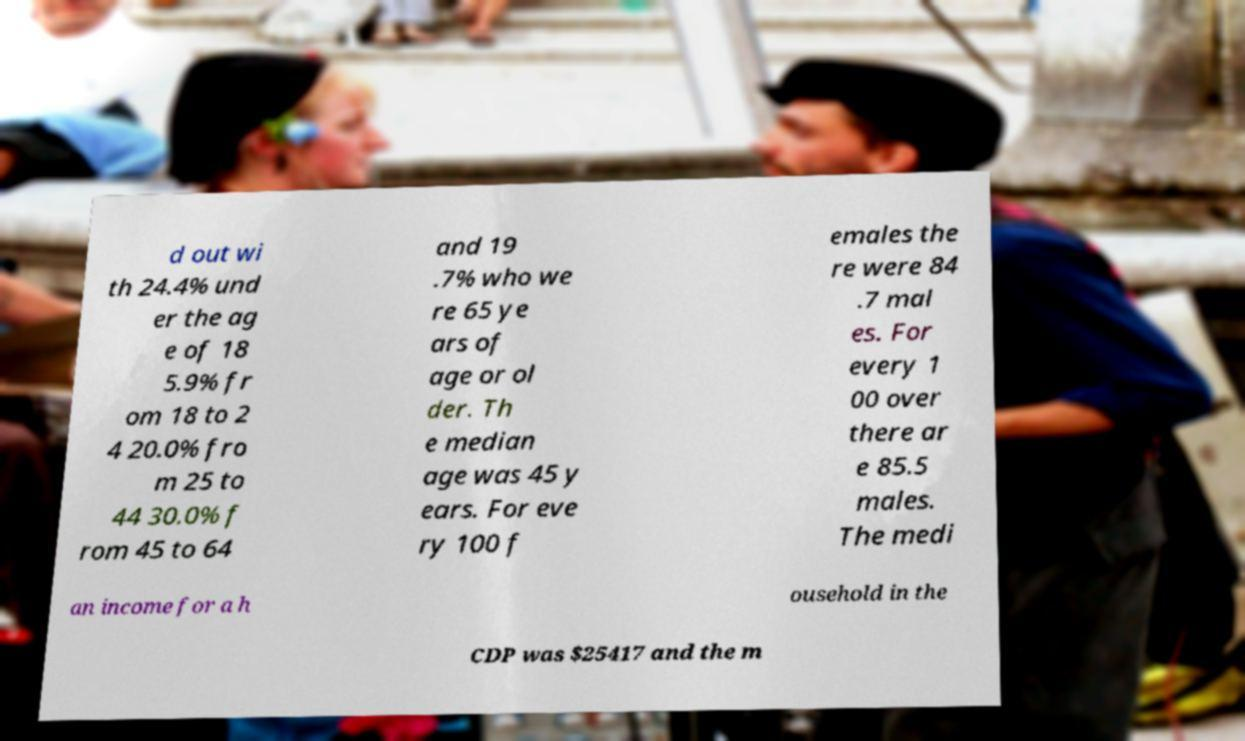There's text embedded in this image that I need extracted. Can you transcribe it verbatim? d out wi th 24.4% und er the ag e of 18 5.9% fr om 18 to 2 4 20.0% fro m 25 to 44 30.0% f rom 45 to 64 and 19 .7% who we re 65 ye ars of age or ol der. Th e median age was 45 y ears. For eve ry 100 f emales the re were 84 .7 mal es. For every 1 00 over there ar e 85.5 males. The medi an income for a h ousehold in the CDP was $25417 and the m 